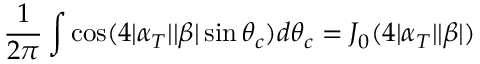Convert formula to latex. <formula><loc_0><loc_0><loc_500><loc_500>\frac { 1 } { 2 \pi } \int \cos ( 4 | \alpha _ { T } | | \beta | \sin \theta _ { c } ) d \theta _ { c } = J _ { 0 } ( 4 | \alpha _ { T } | | \beta | )</formula> 